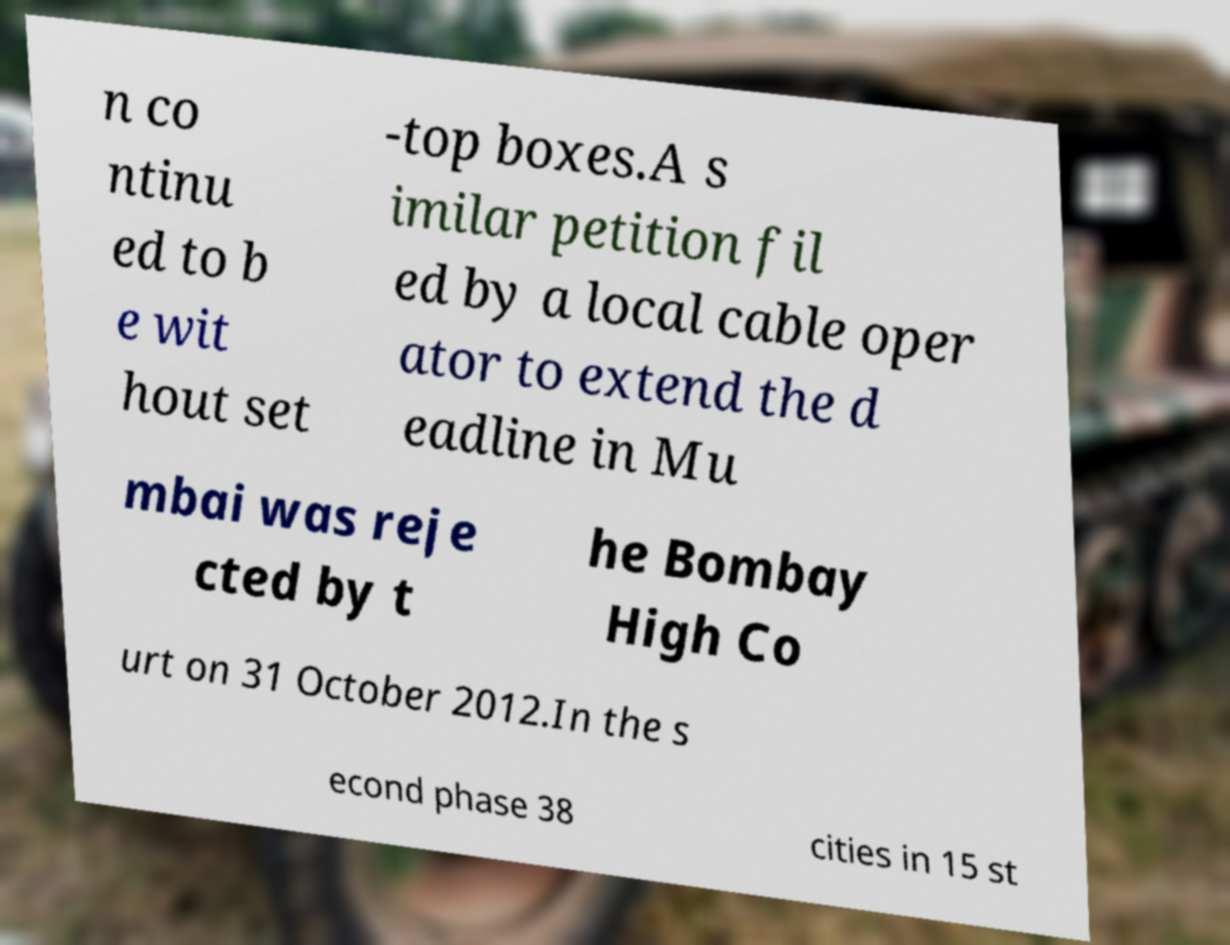There's text embedded in this image that I need extracted. Can you transcribe it verbatim? n co ntinu ed to b e wit hout set -top boxes.A s imilar petition fil ed by a local cable oper ator to extend the d eadline in Mu mbai was reje cted by t he Bombay High Co urt on 31 October 2012.In the s econd phase 38 cities in 15 st 